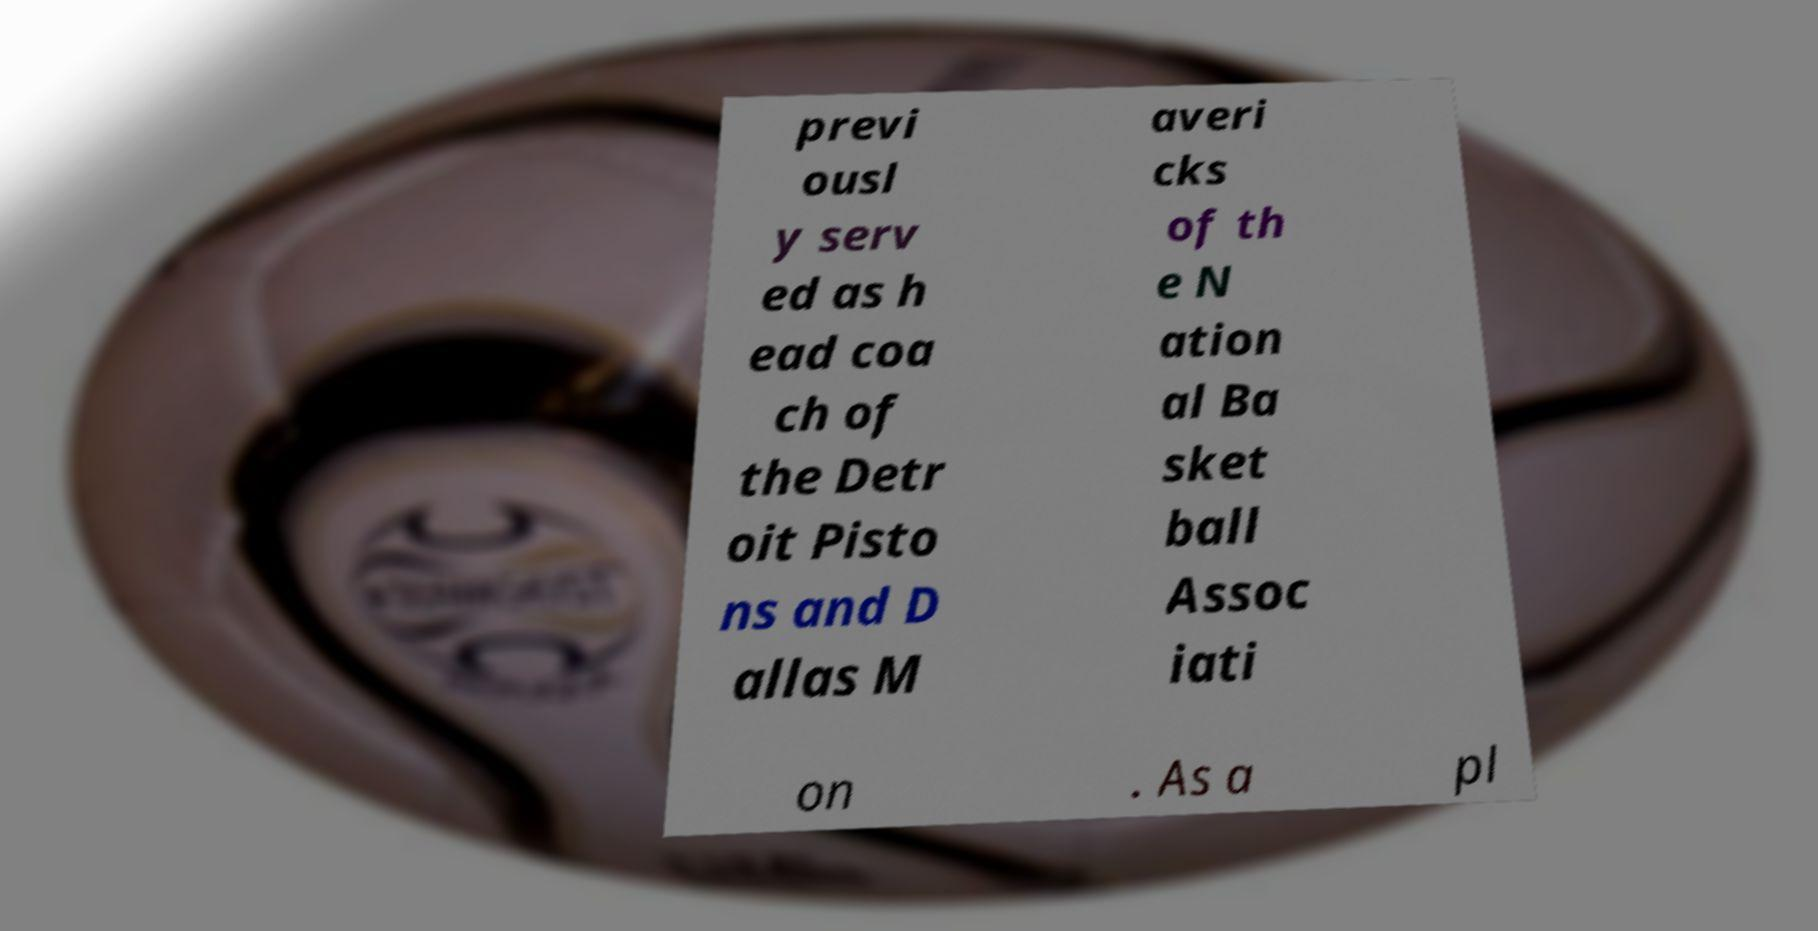Could you extract and type out the text from this image? previ ousl y serv ed as h ead coa ch of the Detr oit Pisto ns and D allas M averi cks of th e N ation al Ba sket ball Assoc iati on . As a pl 